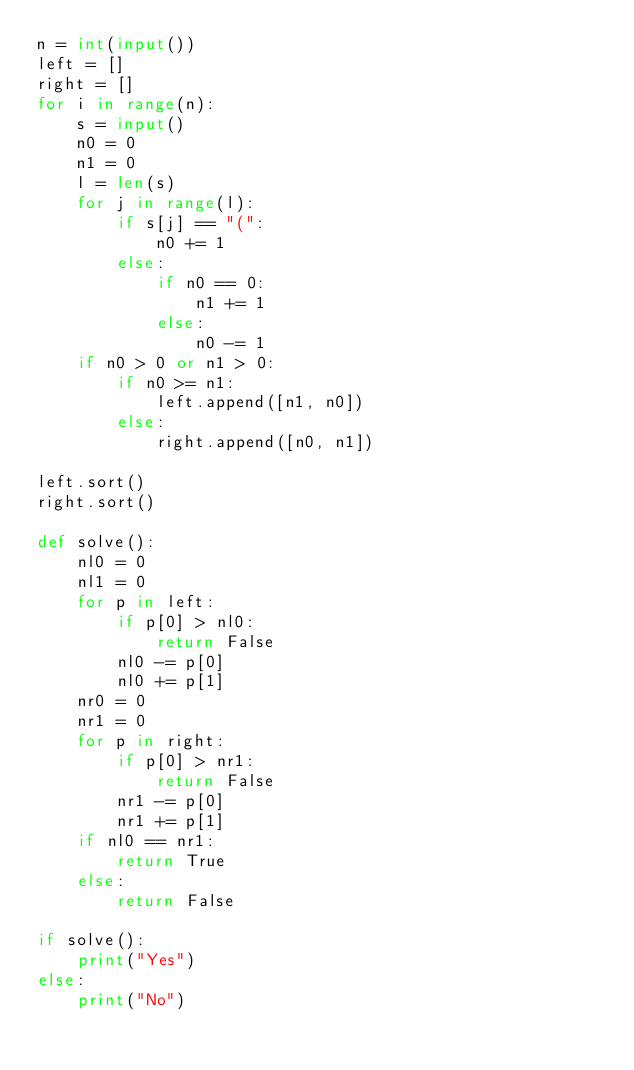Convert code to text. <code><loc_0><loc_0><loc_500><loc_500><_Python_>n = int(input())
left = []
right = []
for i in range(n):
    s = input()
    n0 = 0
    n1 = 0
    l = len(s)
    for j in range(l):
        if s[j] == "(":
            n0 += 1
        else:
            if n0 == 0:
                n1 += 1
            else:
                n0 -= 1
    if n0 > 0 or n1 > 0:
        if n0 >= n1:
            left.append([n1, n0])
        else:
            right.append([n0, n1])
 
left.sort()
right.sort()
 
def solve():
    nl0 = 0
    nl1 = 0
    for p in left:
        if p[0] > nl0:
            return False
        nl0 -= p[0]
        nl0 += p[1]
    nr0 = 0
    nr1 = 0
    for p in right:
        if p[0] > nr1:
            return False
        nr1 -= p[0]
        nr1 += p[1]
    if nl0 == nr1:
        return True
    else:
        return False
 
if solve():
    print("Yes")
else:
    print("No")</code> 